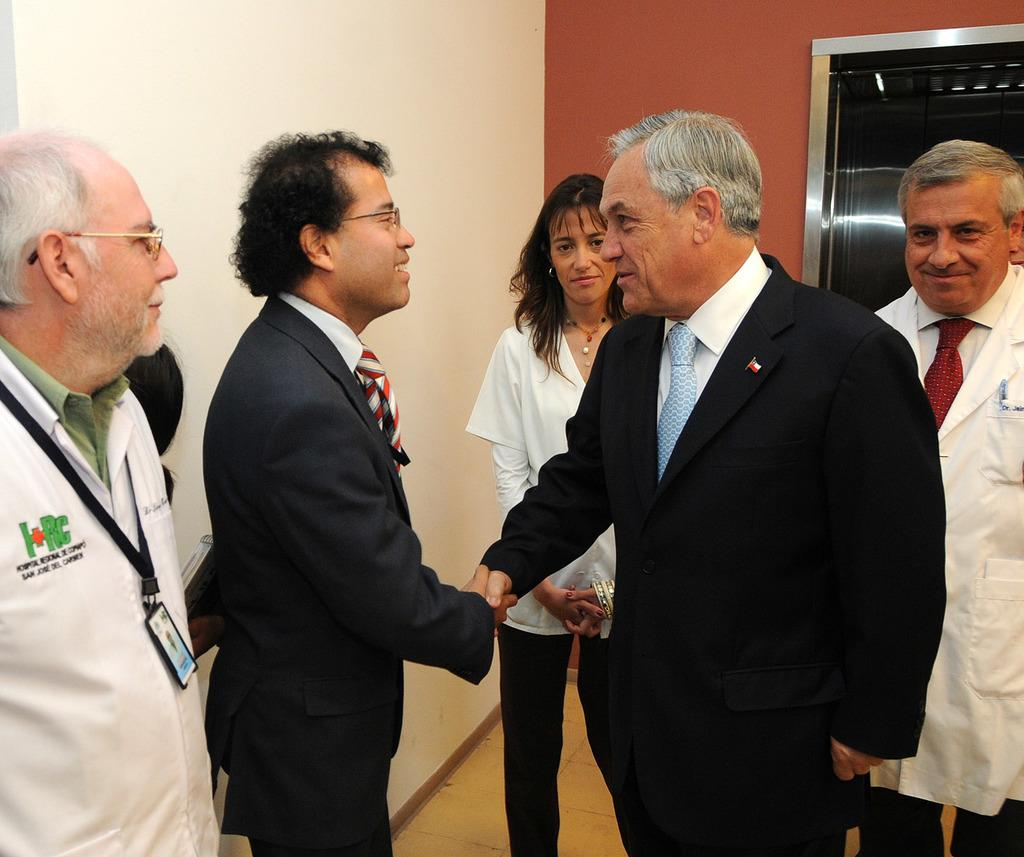What is the main subject of the image? The main subject of the image is a group of people. Can you describe any specific features of the people in the image? Some people in the group are wearing spectacles. Where is the man located in the image? The man is on the left side of the image. What is the man wearing in the image? The man is wearing a tag. What type of boats can be seen in the image? There are no boats present in the image. What caption is written on the tag the man is wearing? The image does not provide any information about the caption on the tag, as it only mentions the presence of a tag. --- Facts: 1. There is a car in the image. 2. The car is parked on the street. 3. There are trees on both sides of the street. 4. The sky is visible in the image. Absurd Topics: parrot, volcano, dance Conversation: What is the main subject of the image? The main subject of the image is a car. Where is the car located in the image? The car is parked on the street. What can be seen on both sides of the street in the image? There are trees on both sides of the street. What is visible in the background of the image? The sky is visible in the image. Reasoning: Let's think step by step in order to produce the conversation. We start by identifying the main subject of the image, which is the car. Then, we describe the location of the car, which is parked on the street. Next, we mention the trees on both sides of the street and the visible sky in the background. Each question is designed to elicit a specific detail about the image that is known from the provided facts. Absurd Question/Answer: Can you see a parrot perched on the car in the image? There is no parrot present in the image. Is there a volcano erupting in the background of the image? There is no volcano present in the image. 